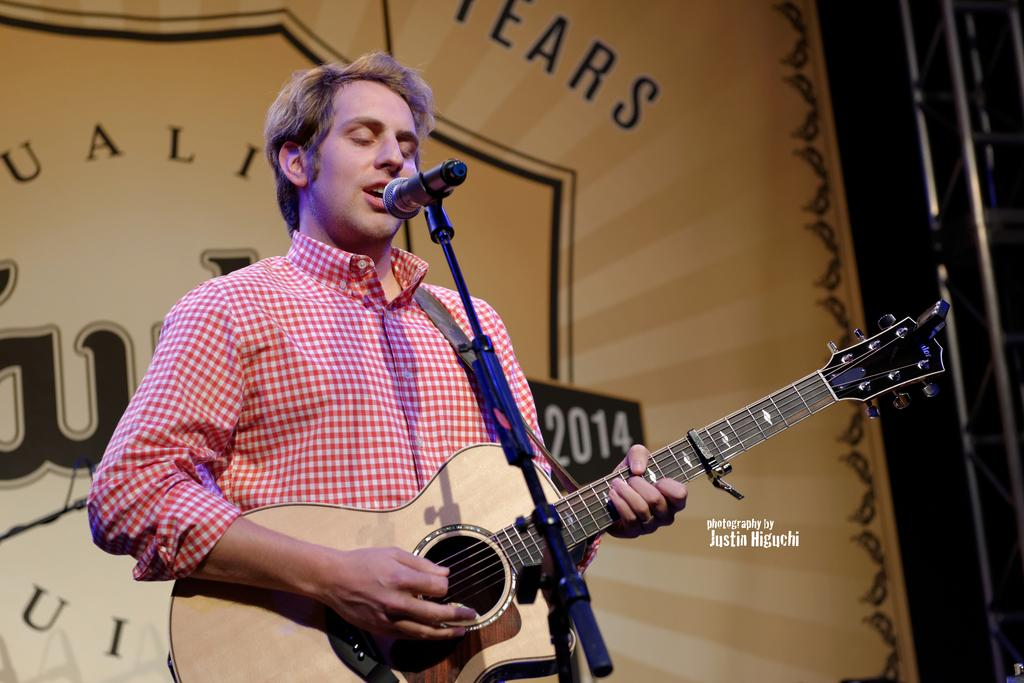What is the person in the image doing? The person in the image is playing a guitar and singing into a microphone. What instrument is the person playing? The person is playing a guitar. How is the person's voice being amplified? The person is singing into a microphone. What type of animal is playing the guitar in the image? There is no animal present in the image; it is a person playing the guitar. What part of the guitar is made of jelly in the image? There is no jelly or any part of the guitar made of jelly in the image. 